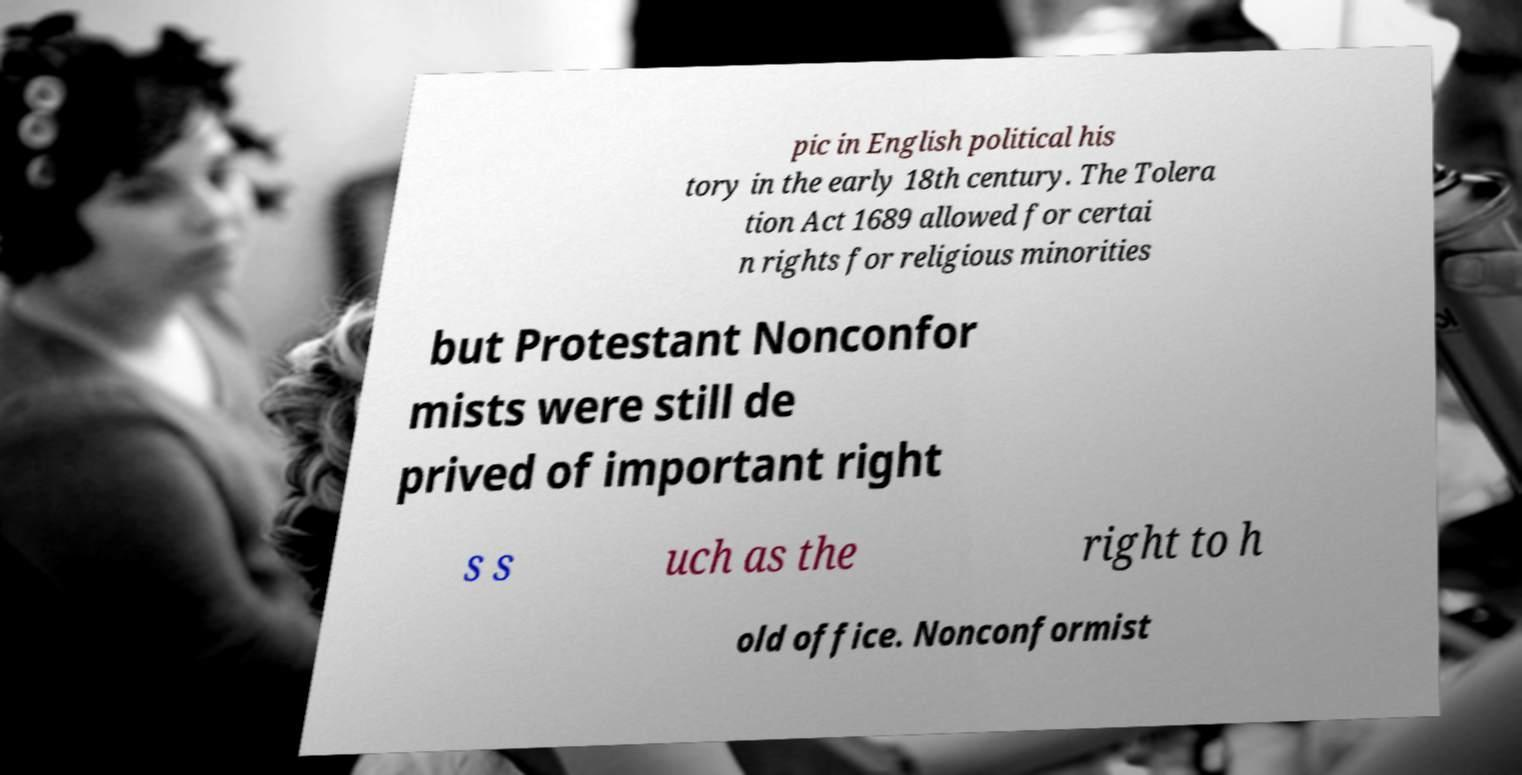I need the written content from this picture converted into text. Can you do that? pic in English political his tory in the early 18th century. The Tolera tion Act 1689 allowed for certai n rights for religious minorities but Protestant Nonconfor mists were still de prived of important right s s uch as the right to h old office. Nonconformist 